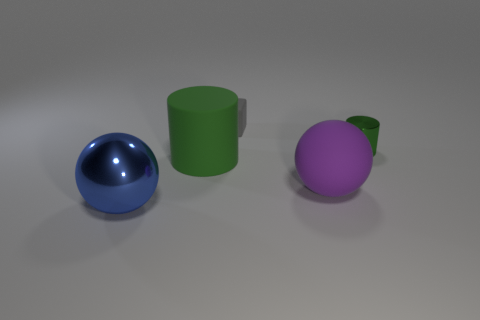What material is the green object behind the green thing in front of the metallic thing that is to the right of the blue sphere?
Provide a succinct answer. Metal. How many tiny things are green rubber objects or purple balls?
Offer a very short reply. 0. Are there any objects of the same color as the metallic cylinder?
Provide a short and direct response. Yes. The green metallic thing that is the same size as the gray object is what shape?
Offer a very short reply. Cylinder. There is a shiny thing that is to the right of the blue sphere; does it have the same color as the big matte cylinder?
Offer a terse response. Yes. What number of things are objects that are in front of the tiny green shiny cylinder or purple objects?
Offer a very short reply. 3. Is the number of large purple rubber spheres on the right side of the shiny sphere greater than the number of matte blocks in front of the purple object?
Give a very brief answer. Yes. Is the material of the big cylinder the same as the big blue thing?
Give a very brief answer. No. What shape is the object that is behind the matte cylinder and right of the gray block?
Offer a very short reply. Cylinder. There is a big blue thing that is the same material as the tiny cylinder; what is its shape?
Ensure brevity in your answer.  Sphere. 